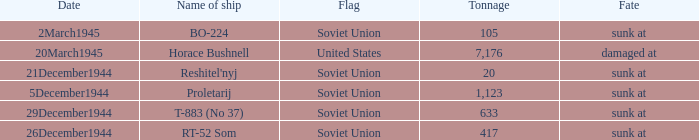What is the average tonnage of the ship named proletarij? 1123.0. 